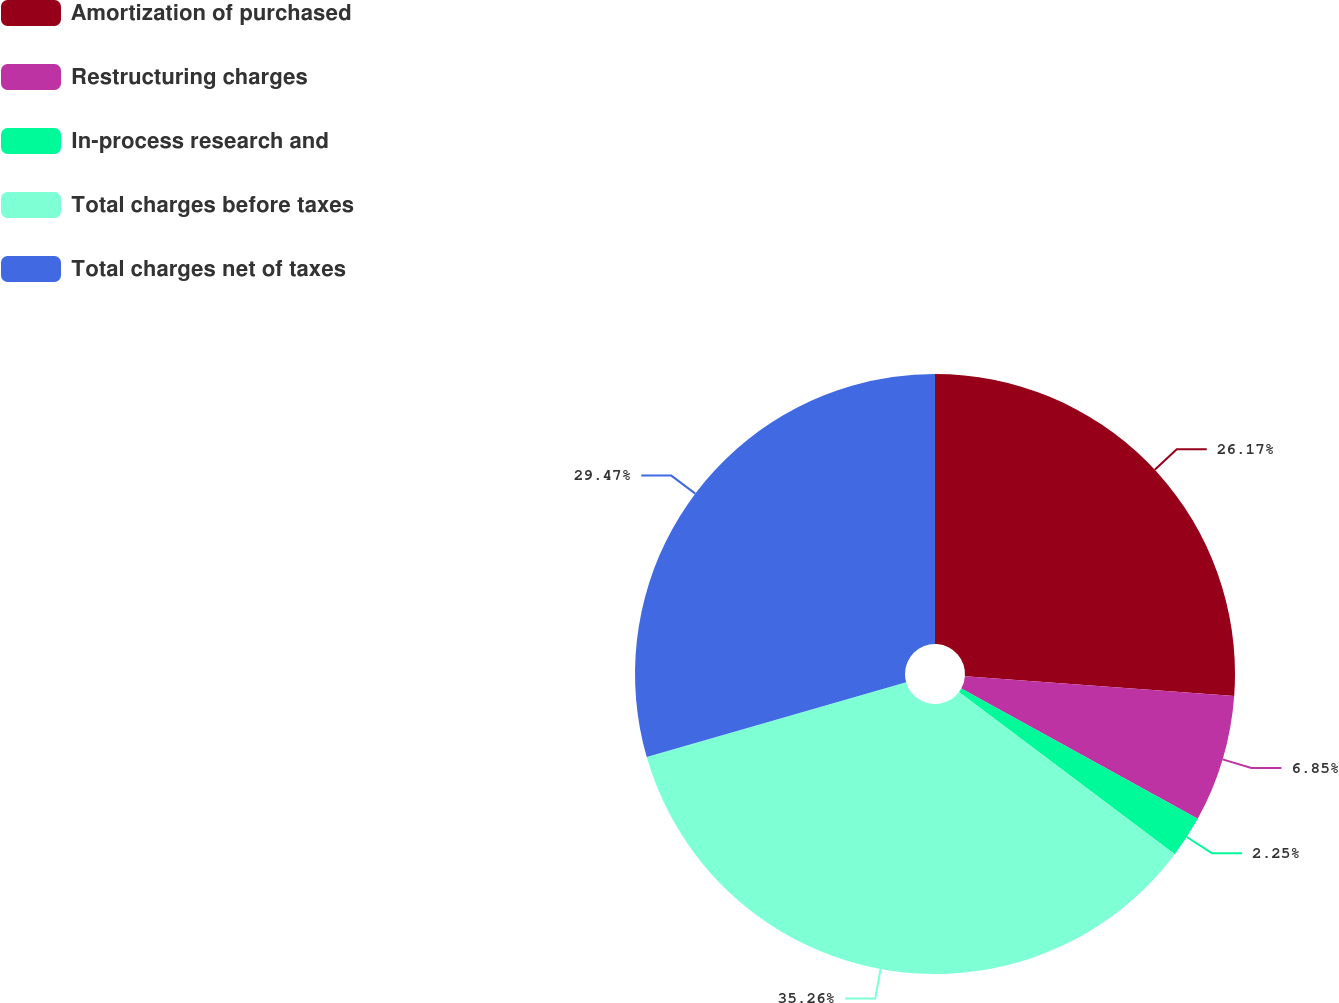Convert chart to OTSL. <chart><loc_0><loc_0><loc_500><loc_500><pie_chart><fcel>Amortization of purchased<fcel>Restructuring charges<fcel>In-process research and<fcel>Total charges before taxes<fcel>Total charges net of taxes<nl><fcel>26.17%<fcel>6.85%<fcel>2.25%<fcel>35.27%<fcel>29.47%<nl></chart> 